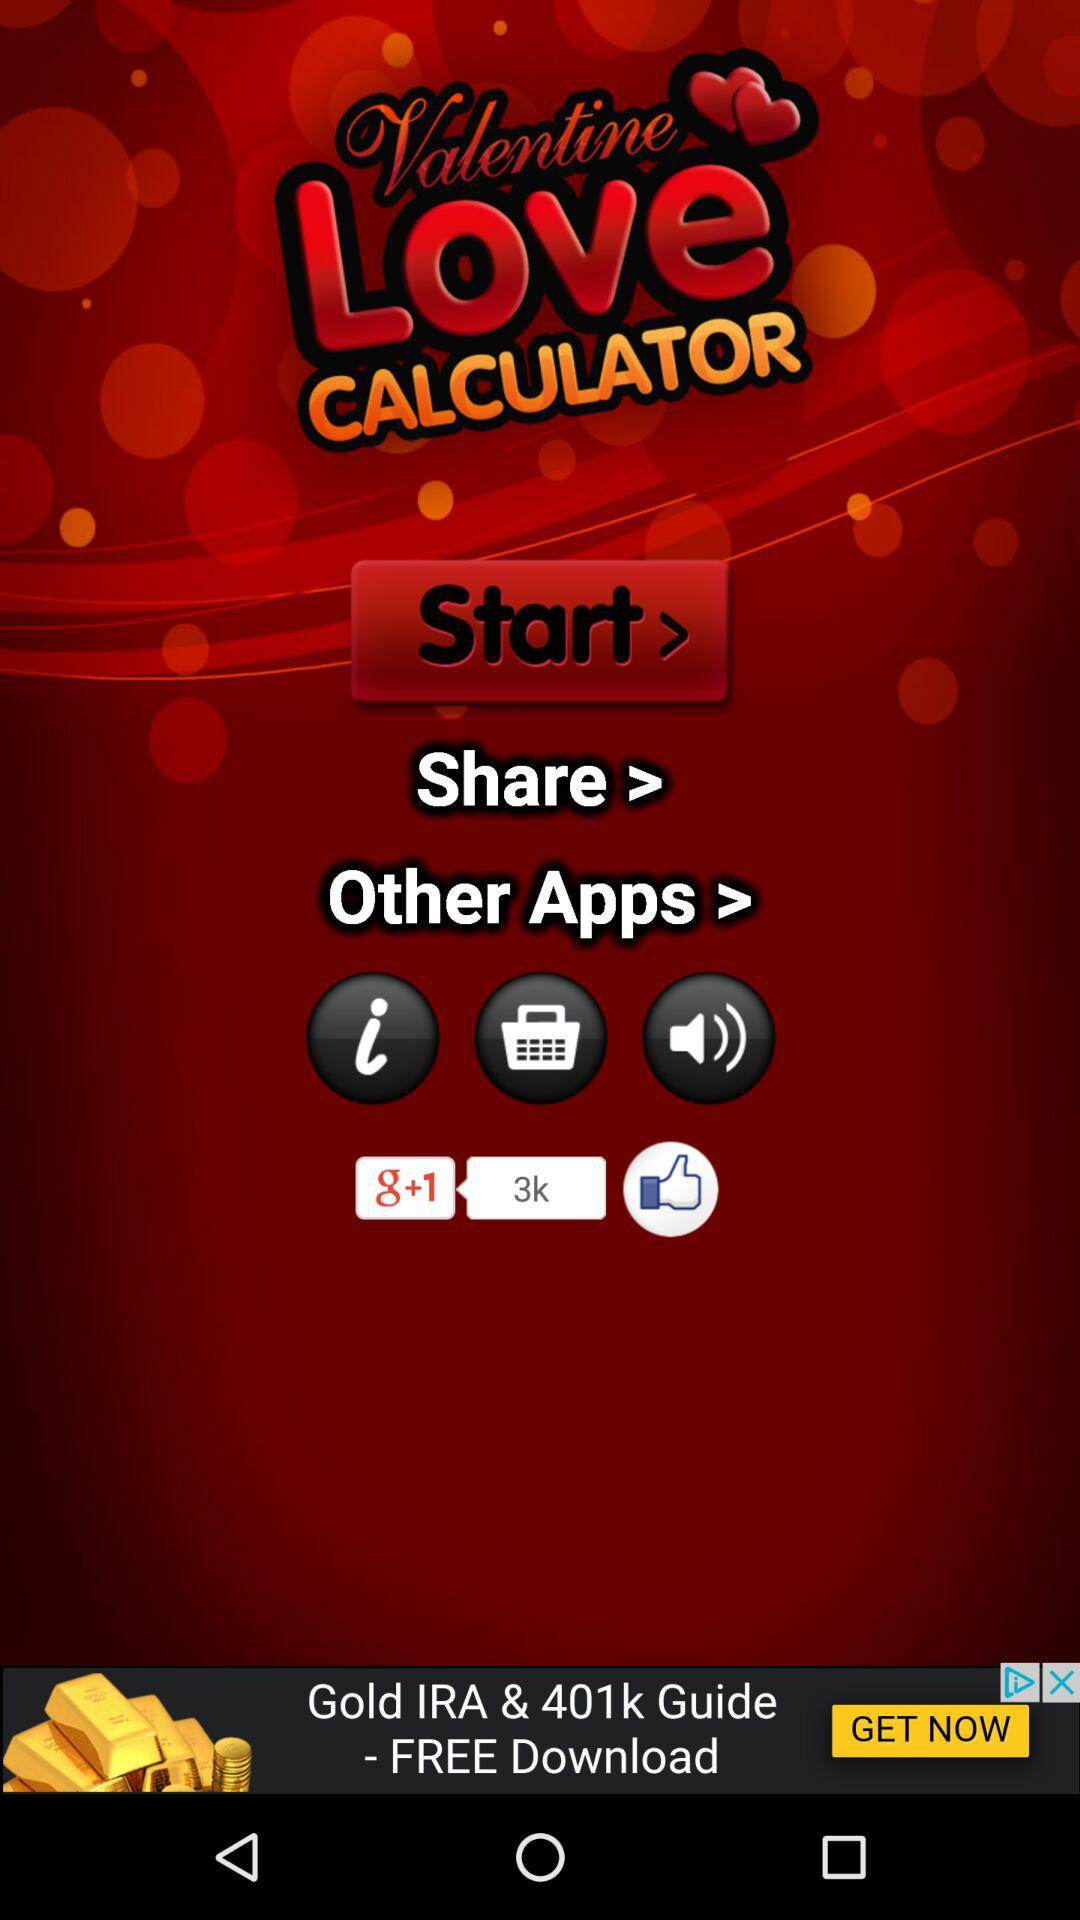What is the name of the application? The application name is "Valentine Love CALCULATOR". 